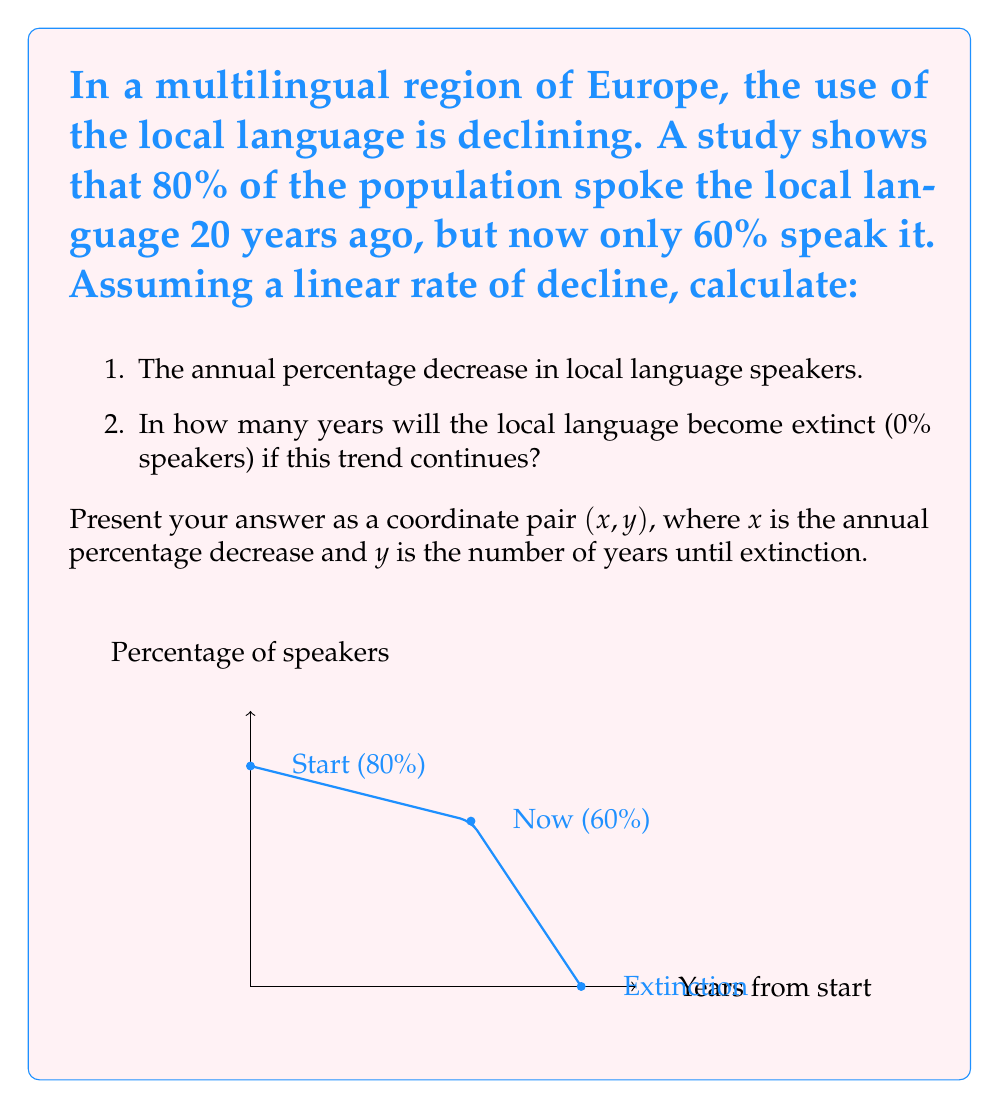Can you solve this math problem? Let's approach this step-by-step:

1. Calculate the annual percentage decrease:
   - Total decrease over 20 years: $80\% - 60\% = 20\%$
   - Annual decrease: $\frac{20\%}{20 \text{ years}} = 1\%$ per year

2. Calculate years until extinction:
   - Current percentage: $60\%$
   - Rate of decline: $1\%$ per year
   - Years until $0\%$: $\frac{60\%}{1\% \text{ per year}} = 60 \text{ years}$

The linear equation for the percentage of speakers $P$ after $t$ years from now is:
$$ P = 60\% - 1\% \cdot t $$

Setting $P = 0\%$ and solving for $t$:
$$ 0\% = 60\% - 1\% \cdot t $$
$$ t = 60 \text{ years} $$

This confirms our calculation.
Answer: $(1, 60)$ 